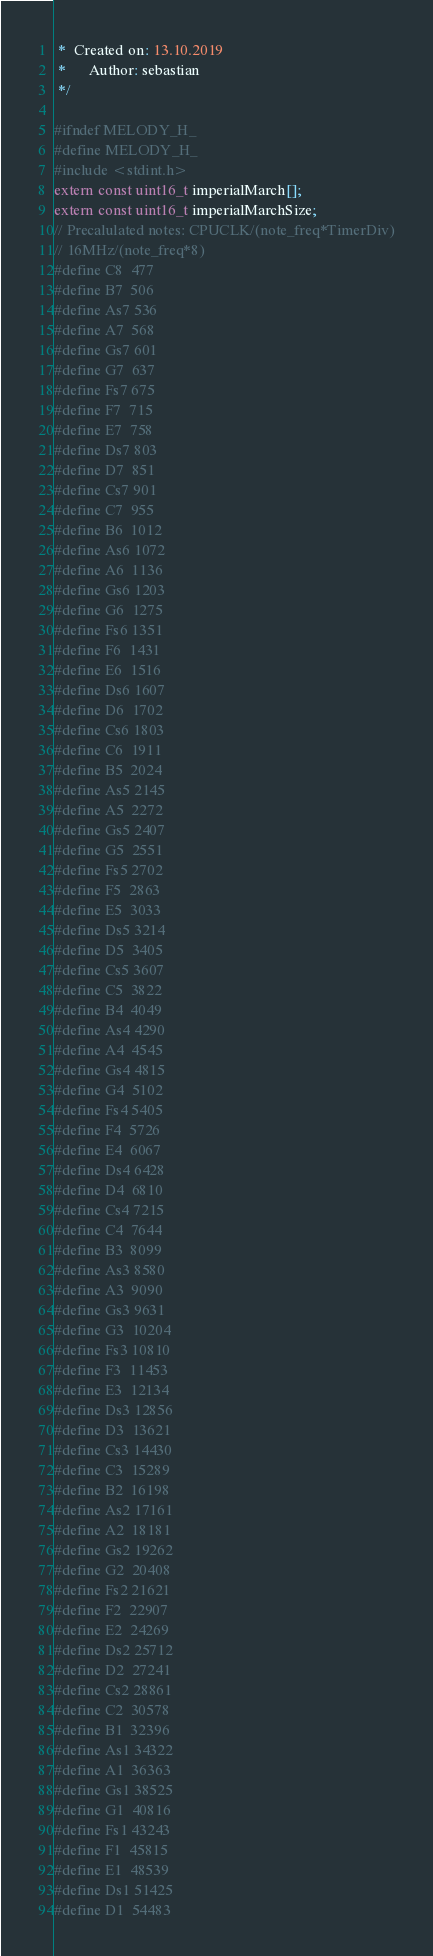<code> <loc_0><loc_0><loc_500><loc_500><_C_> *  Created on: 13.10.2019
 *      Author: sebastian
 */

#ifndef MELODY_H_
#define MELODY_H_
#include <stdint.h>
extern const uint16_t imperialMarch[];
extern const uint16_t imperialMarchSize;
// Precalulated notes: CPUCLK/(note_freq*TimerDiv)
// 16MHz/(note_freq*8)
#define C8  477
#define B7  506
#define As7 536
#define A7  568
#define Gs7 601
#define G7  637
#define Fs7 675
#define F7  715
#define E7  758
#define Ds7 803
#define D7  851
#define Cs7 901
#define C7  955
#define B6  1012
#define As6 1072
#define A6  1136
#define Gs6 1203
#define G6  1275
#define Fs6 1351
#define F6  1431
#define E6  1516
#define Ds6 1607
#define D6  1702
#define Cs6 1803
#define C6  1911
#define B5  2024
#define As5 2145
#define A5  2272
#define Gs5 2407
#define G5  2551
#define Fs5 2702
#define F5  2863
#define E5  3033
#define Ds5 3214
#define D5  3405
#define Cs5 3607
#define C5  3822
#define B4  4049
#define As4 4290
#define A4  4545
#define Gs4 4815
#define G4  5102
#define Fs4 5405
#define F4  5726
#define E4  6067
#define Ds4 6428
#define D4  6810
#define Cs4 7215
#define C4  7644
#define B3  8099
#define As3 8580
#define A3  9090
#define Gs3 9631
#define G3  10204
#define Fs3 10810
#define F3  11453
#define E3  12134
#define Ds3 12856
#define D3  13621
#define Cs3 14430
#define C3  15289
#define B2  16198
#define As2 17161
#define A2  18181
#define Gs2 19262
#define G2  20408
#define Fs2 21621
#define F2  22907
#define E2  24269
#define Ds2 25712
#define D2  27241
#define Cs2 28861
#define C2  30578
#define B1  32396
#define As1 34322
#define A1  36363
#define Gs1 38525
#define G1  40816
#define Fs1 43243
#define F1  45815
#define E1  48539
#define Ds1 51425
#define D1  54483</code> 